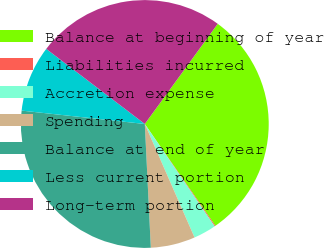<chart> <loc_0><loc_0><loc_500><loc_500><pie_chart><fcel>Balance at beginning of year<fcel>Liabilities incurred<fcel>Accretion expense<fcel>Spending<fcel>Balance at end of year<fcel>Less current portion<fcel>Long-term portion<nl><fcel>30.33%<fcel>0.12%<fcel>2.96%<fcel>5.8%<fcel>27.49%<fcel>8.64%<fcel>24.65%<nl></chart> 